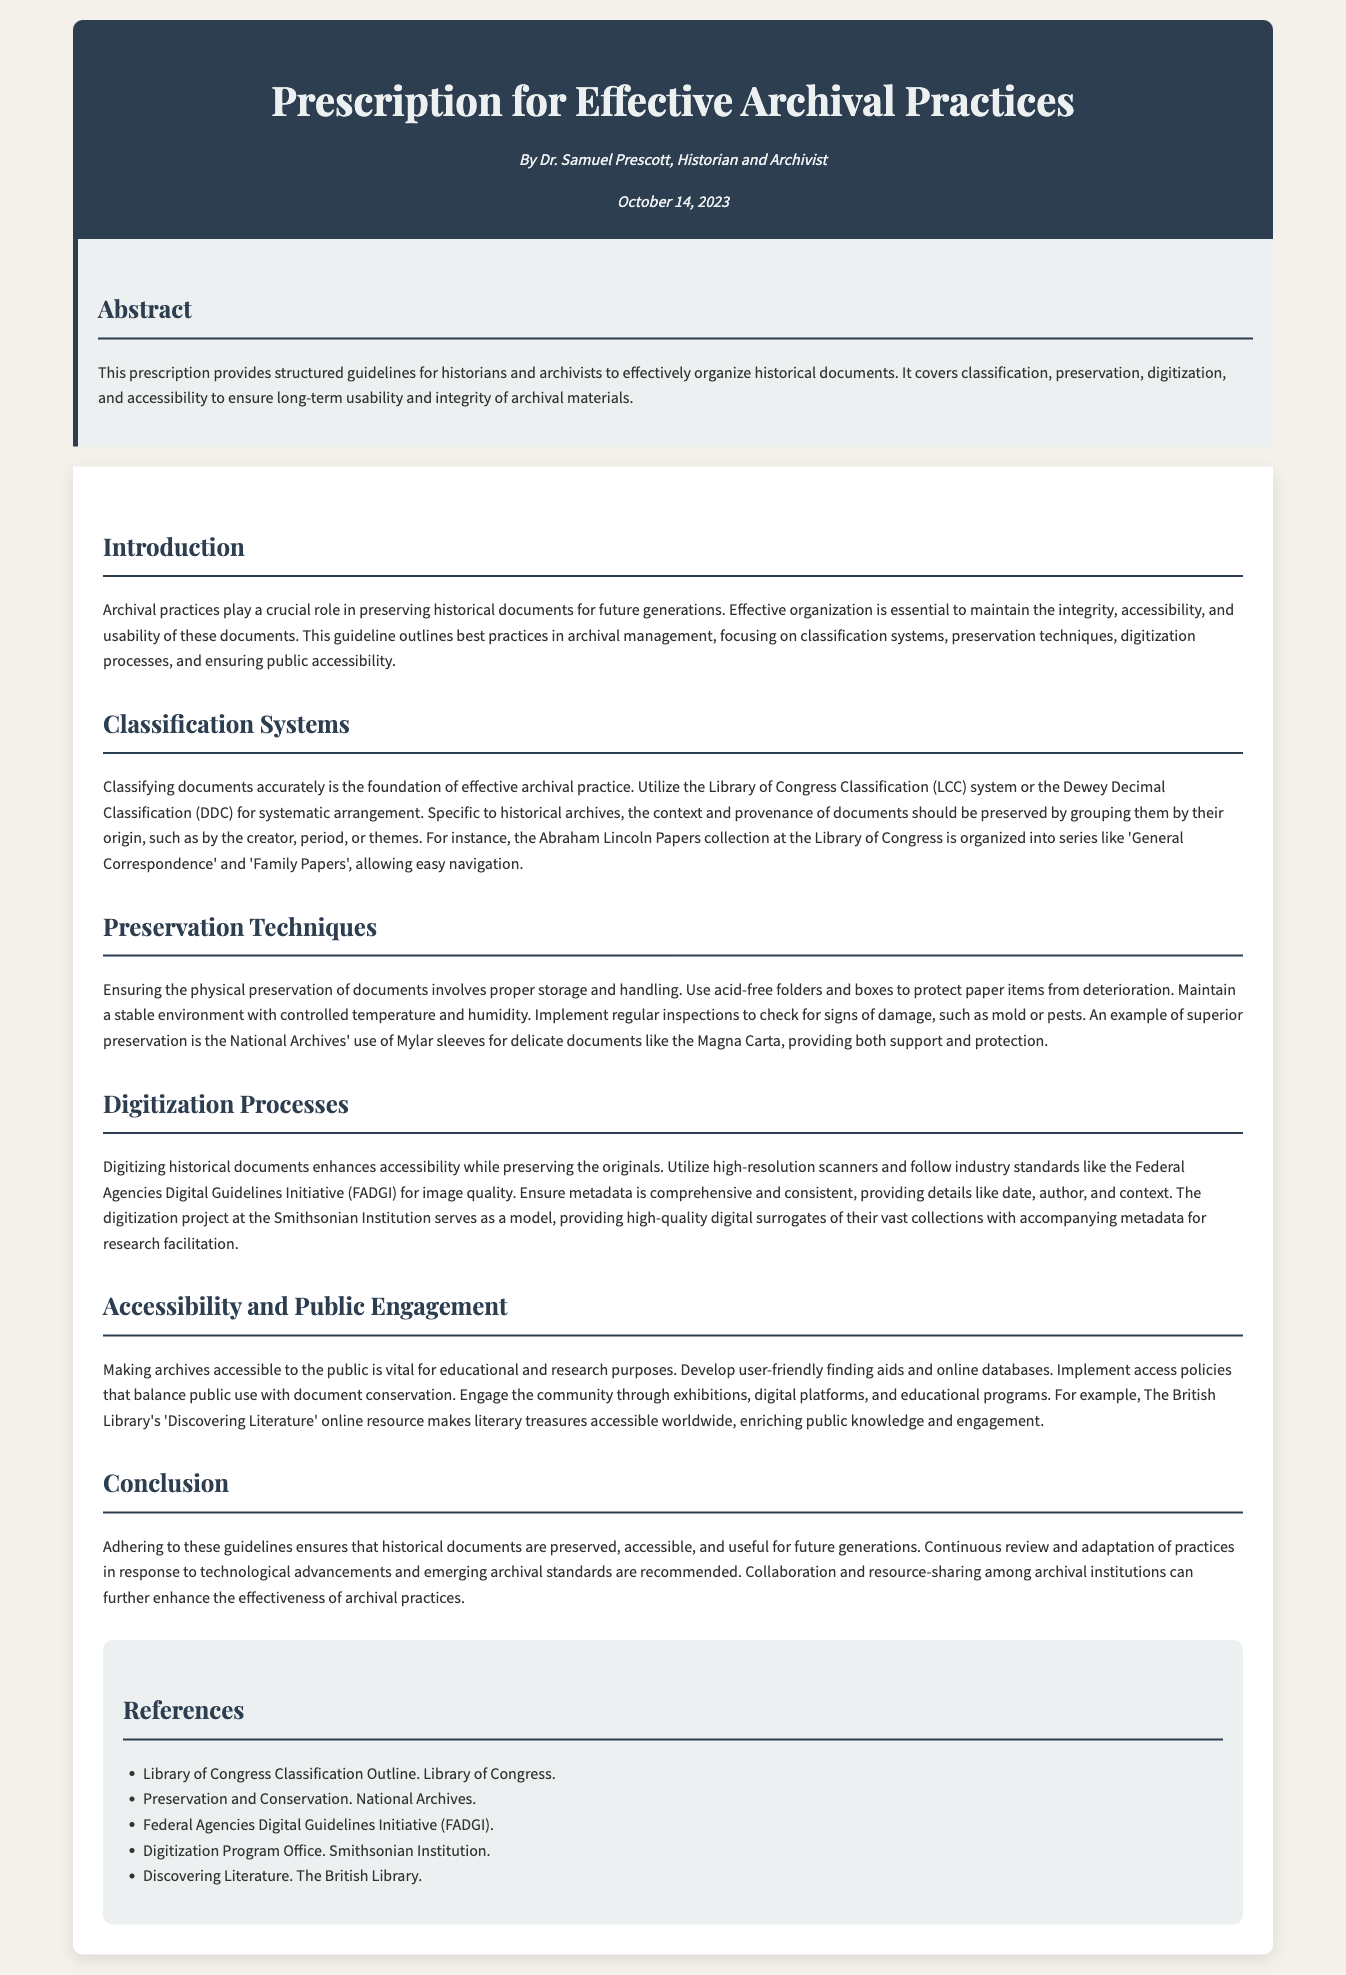What is the title of the document? The title of the document is presented prominently at the top of the header section.
Answer: Prescription for Effective Archival Practices Who is the author of the document? The author's name is mentioned below the title in the header section.
Answer: Dr. Samuel Prescott When was the document published? The publication date is stated in the header section, providing clear information on when the document was completed.
Answer: October 14, 2023 Which classification system is recommended for organizing documents? Specific classification systems are mentioned in the guideline for historical documents organization.
Answer: Library of Congress Classification (LCC) or Dewey Decimal Classification (DDC) What type of sleeves does the National Archives use for delicate documents? The document references a specific preservation method for protecting important historical items.
Answer: Mylar sleeves What is the model project mentioned for digitization processes? The document references a well-known institution that exemplifies digitization efforts.
Answer: Smithsonian Institution What does the document suggest for community engagement? Suggestions for engaging with the community are listed under accessibility and public engagement.
Answer: Exhibitions, digital platforms, and educational programs What is emphasized as essential for the integrity of archival documents? This key aspect is mentioned in the introduction as a fundamental principle of archival practices.
Answer: Effective organization What should be used for storing paper items? The document provides specific recommendations for storage materials to protect paper documents.
Answer: Acid-free folders and boxes 